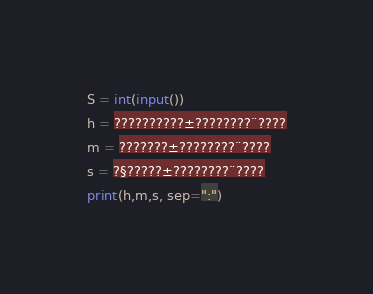<code> <loc_0><loc_0><loc_500><loc_500><_Python_>S = int(input())
h = ??????????±????????¨????
m = ???????±????????¨????
s = ?§?????±????????¨????
print(h,m,s, sep=":")</code> 